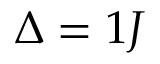Convert formula to latex. <formula><loc_0><loc_0><loc_500><loc_500>\Delta = 1 J</formula> 